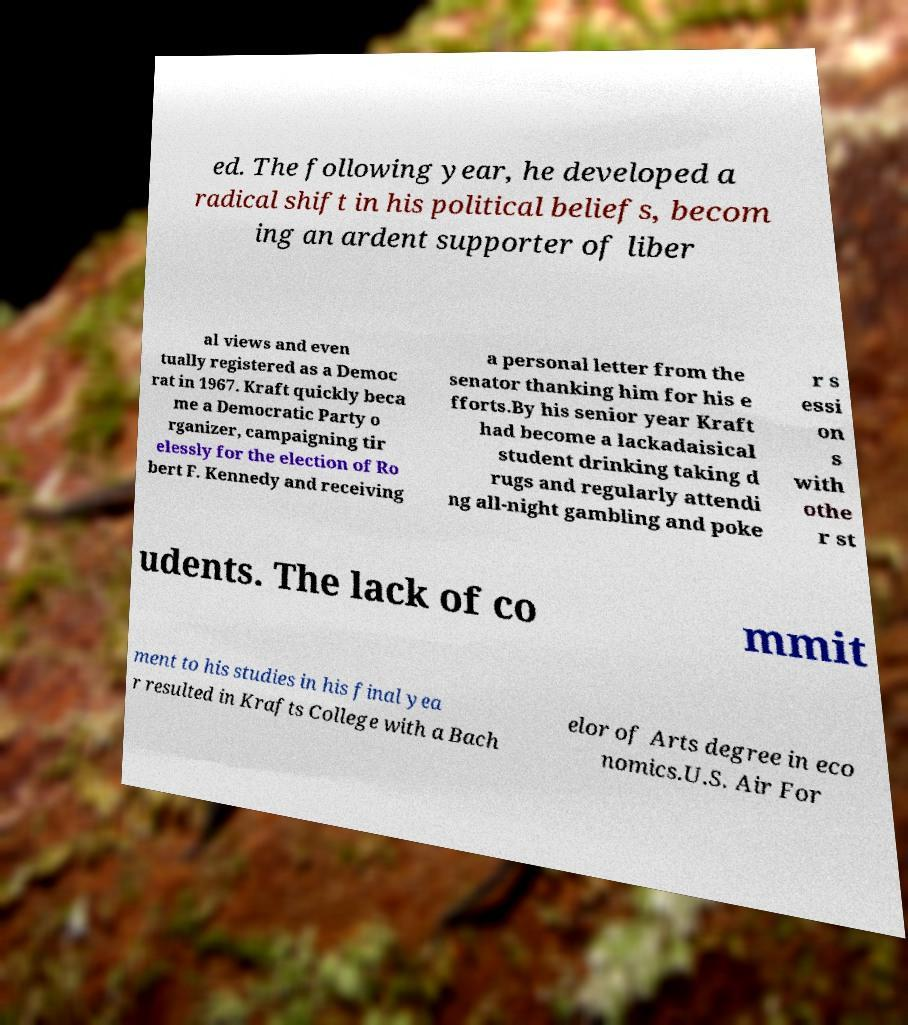Can you read and provide the text displayed in the image?This photo seems to have some interesting text. Can you extract and type it out for me? ed. The following year, he developed a radical shift in his political beliefs, becom ing an ardent supporter of liber al views and even tually registered as a Democ rat in 1967. Kraft quickly beca me a Democratic Party o rganizer, campaigning tir elessly for the election of Ro bert F. Kennedy and receiving a personal letter from the senator thanking him for his e fforts.By his senior year Kraft had become a lackadaisical student drinking taking d rugs and regularly attendi ng all-night gambling and poke r s essi on s with othe r st udents. The lack of co mmit ment to his studies in his final yea r resulted in Krafts College with a Bach elor of Arts degree in eco nomics.U.S. Air For 